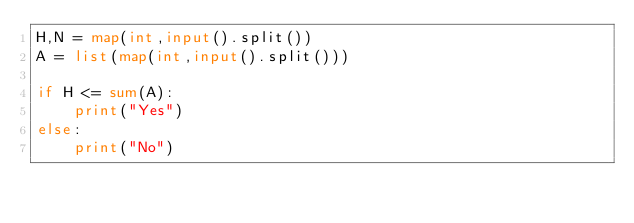<code> <loc_0><loc_0><loc_500><loc_500><_Python_>H,N = map(int,input().split())
A = list(map(int,input().split()))

if H <= sum(A):
    print("Yes")
else:
    print("No")
        </code> 